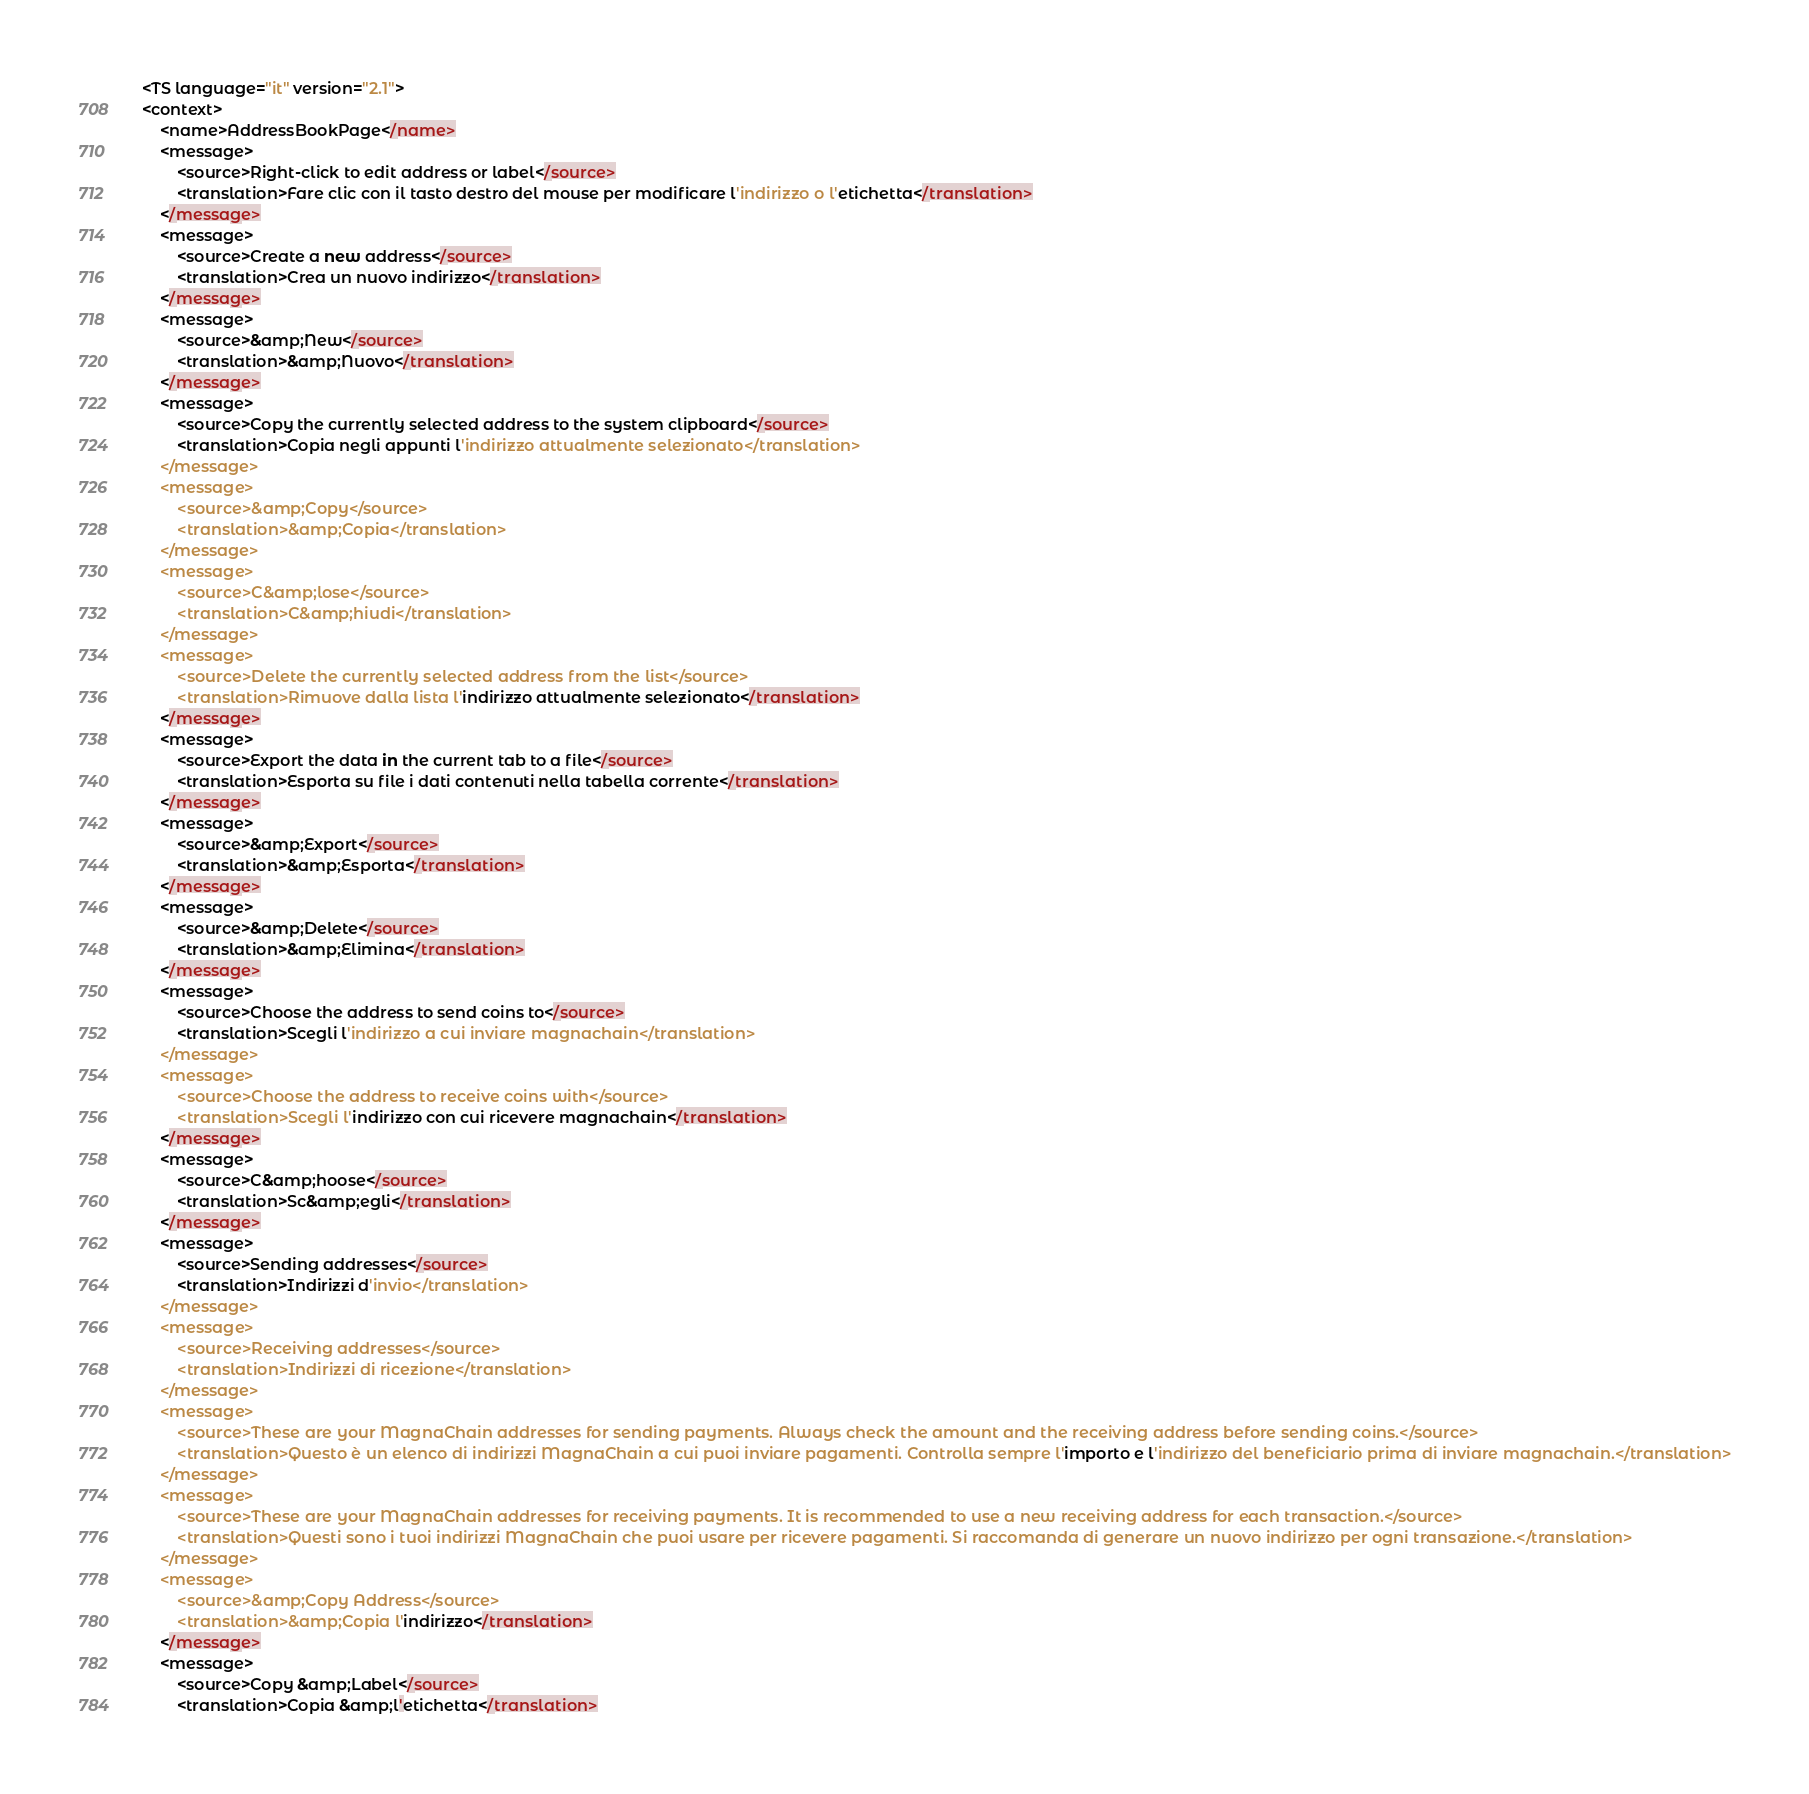<code> <loc_0><loc_0><loc_500><loc_500><_TypeScript_><TS language="it" version="2.1">
<context>
    <name>AddressBookPage</name>
    <message>
        <source>Right-click to edit address or label</source>
        <translation>Fare clic con il tasto destro del mouse per modificare l'indirizzo o l'etichetta</translation>
    </message>
    <message>
        <source>Create a new address</source>
        <translation>Crea un nuovo indirizzo</translation>
    </message>
    <message>
        <source>&amp;New</source>
        <translation>&amp;Nuovo</translation>
    </message>
    <message>
        <source>Copy the currently selected address to the system clipboard</source>
        <translation>Copia negli appunti l'indirizzo attualmente selezionato</translation>
    </message>
    <message>
        <source>&amp;Copy</source>
        <translation>&amp;Copia</translation>
    </message>
    <message>
        <source>C&amp;lose</source>
        <translation>C&amp;hiudi</translation>
    </message>
    <message>
        <source>Delete the currently selected address from the list</source>
        <translation>Rimuove dalla lista l'indirizzo attualmente selezionato</translation>
    </message>
    <message>
        <source>Export the data in the current tab to a file</source>
        <translation>Esporta su file i dati contenuti nella tabella corrente</translation>
    </message>
    <message>
        <source>&amp;Export</source>
        <translation>&amp;Esporta</translation>
    </message>
    <message>
        <source>&amp;Delete</source>
        <translation>&amp;Elimina</translation>
    </message>
    <message>
        <source>Choose the address to send coins to</source>
        <translation>Scegli l'indirizzo a cui inviare magnachain</translation>
    </message>
    <message>
        <source>Choose the address to receive coins with</source>
        <translation>Scegli l'indirizzo con cui ricevere magnachain</translation>
    </message>
    <message>
        <source>C&amp;hoose</source>
        <translation>Sc&amp;egli</translation>
    </message>
    <message>
        <source>Sending addresses</source>
        <translation>Indirizzi d'invio</translation>
    </message>
    <message>
        <source>Receiving addresses</source>
        <translation>Indirizzi di ricezione</translation>
    </message>
    <message>
        <source>These are your MagnaChain addresses for sending payments. Always check the amount and the receiving address before sending coins.</source>
        <translation>Questo è un elenco di indirizzi MagnaChain a cui puoi inviare pagamenti. Controlla sempre l'importo e l'indirizzo del beneficiario prima di inviare magnachain.</translation>
    </message>
    <message>
        <source>These are your MagnaChain addresses for receiving payments. It is recommended to use a new receiving address for each transaction.</source>
        <translation>Questi sono i tuoi indirizzi MagnaChain che puoi usare per ricevere pagamenti. Si raccomanda di generare un nuovo indirizzo per ogni transazione.</translation>
    </message>
    <message>
        <source>&amp;Copy Address</source>
        <translation>&amp;Copia l'indirizzo</translation>
    </message>
    <message>
        <source>Copy &amp;Label</source>
        <translation>Copia &amp;l'etichetta</translation></code> 